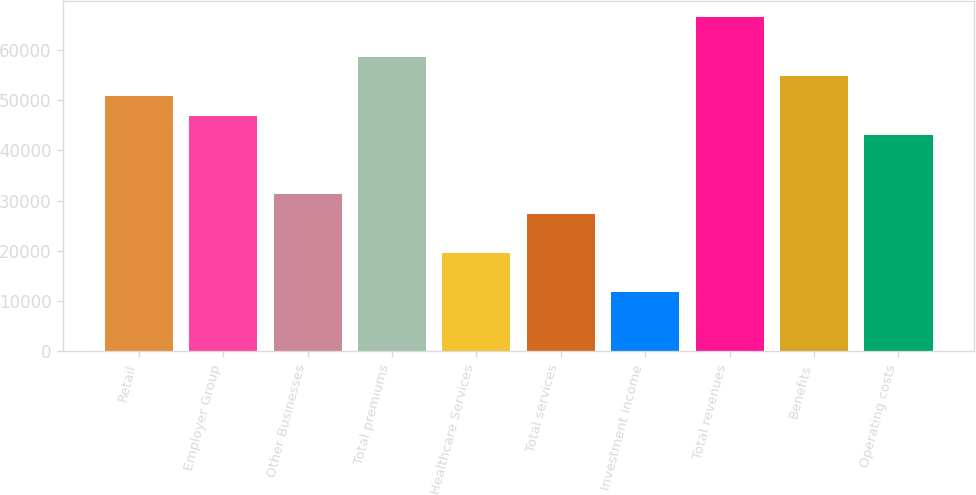Convert chart to OTSL. <chart><loc_0><loc_0><loc_500><loc_500><bar_chart><fcel>Retail<fcel>Employer Group<fcel>Other Businesses<fcel>Total premiums<fcel>Healthcare Services<fcel>Total services<fcel>Investment income<fcel>Total revenues<fcel>Benefits<fcel>Operating costs<nl><fcel>50861.5<fcel>46949.7<fcel>31302.3<fcel>58685.2<fcel>19566.7<fcel>27390.4<fcel>11743<fcel>66508.9<fcel>54773.4<fcel>43037.8<nl></chart> 